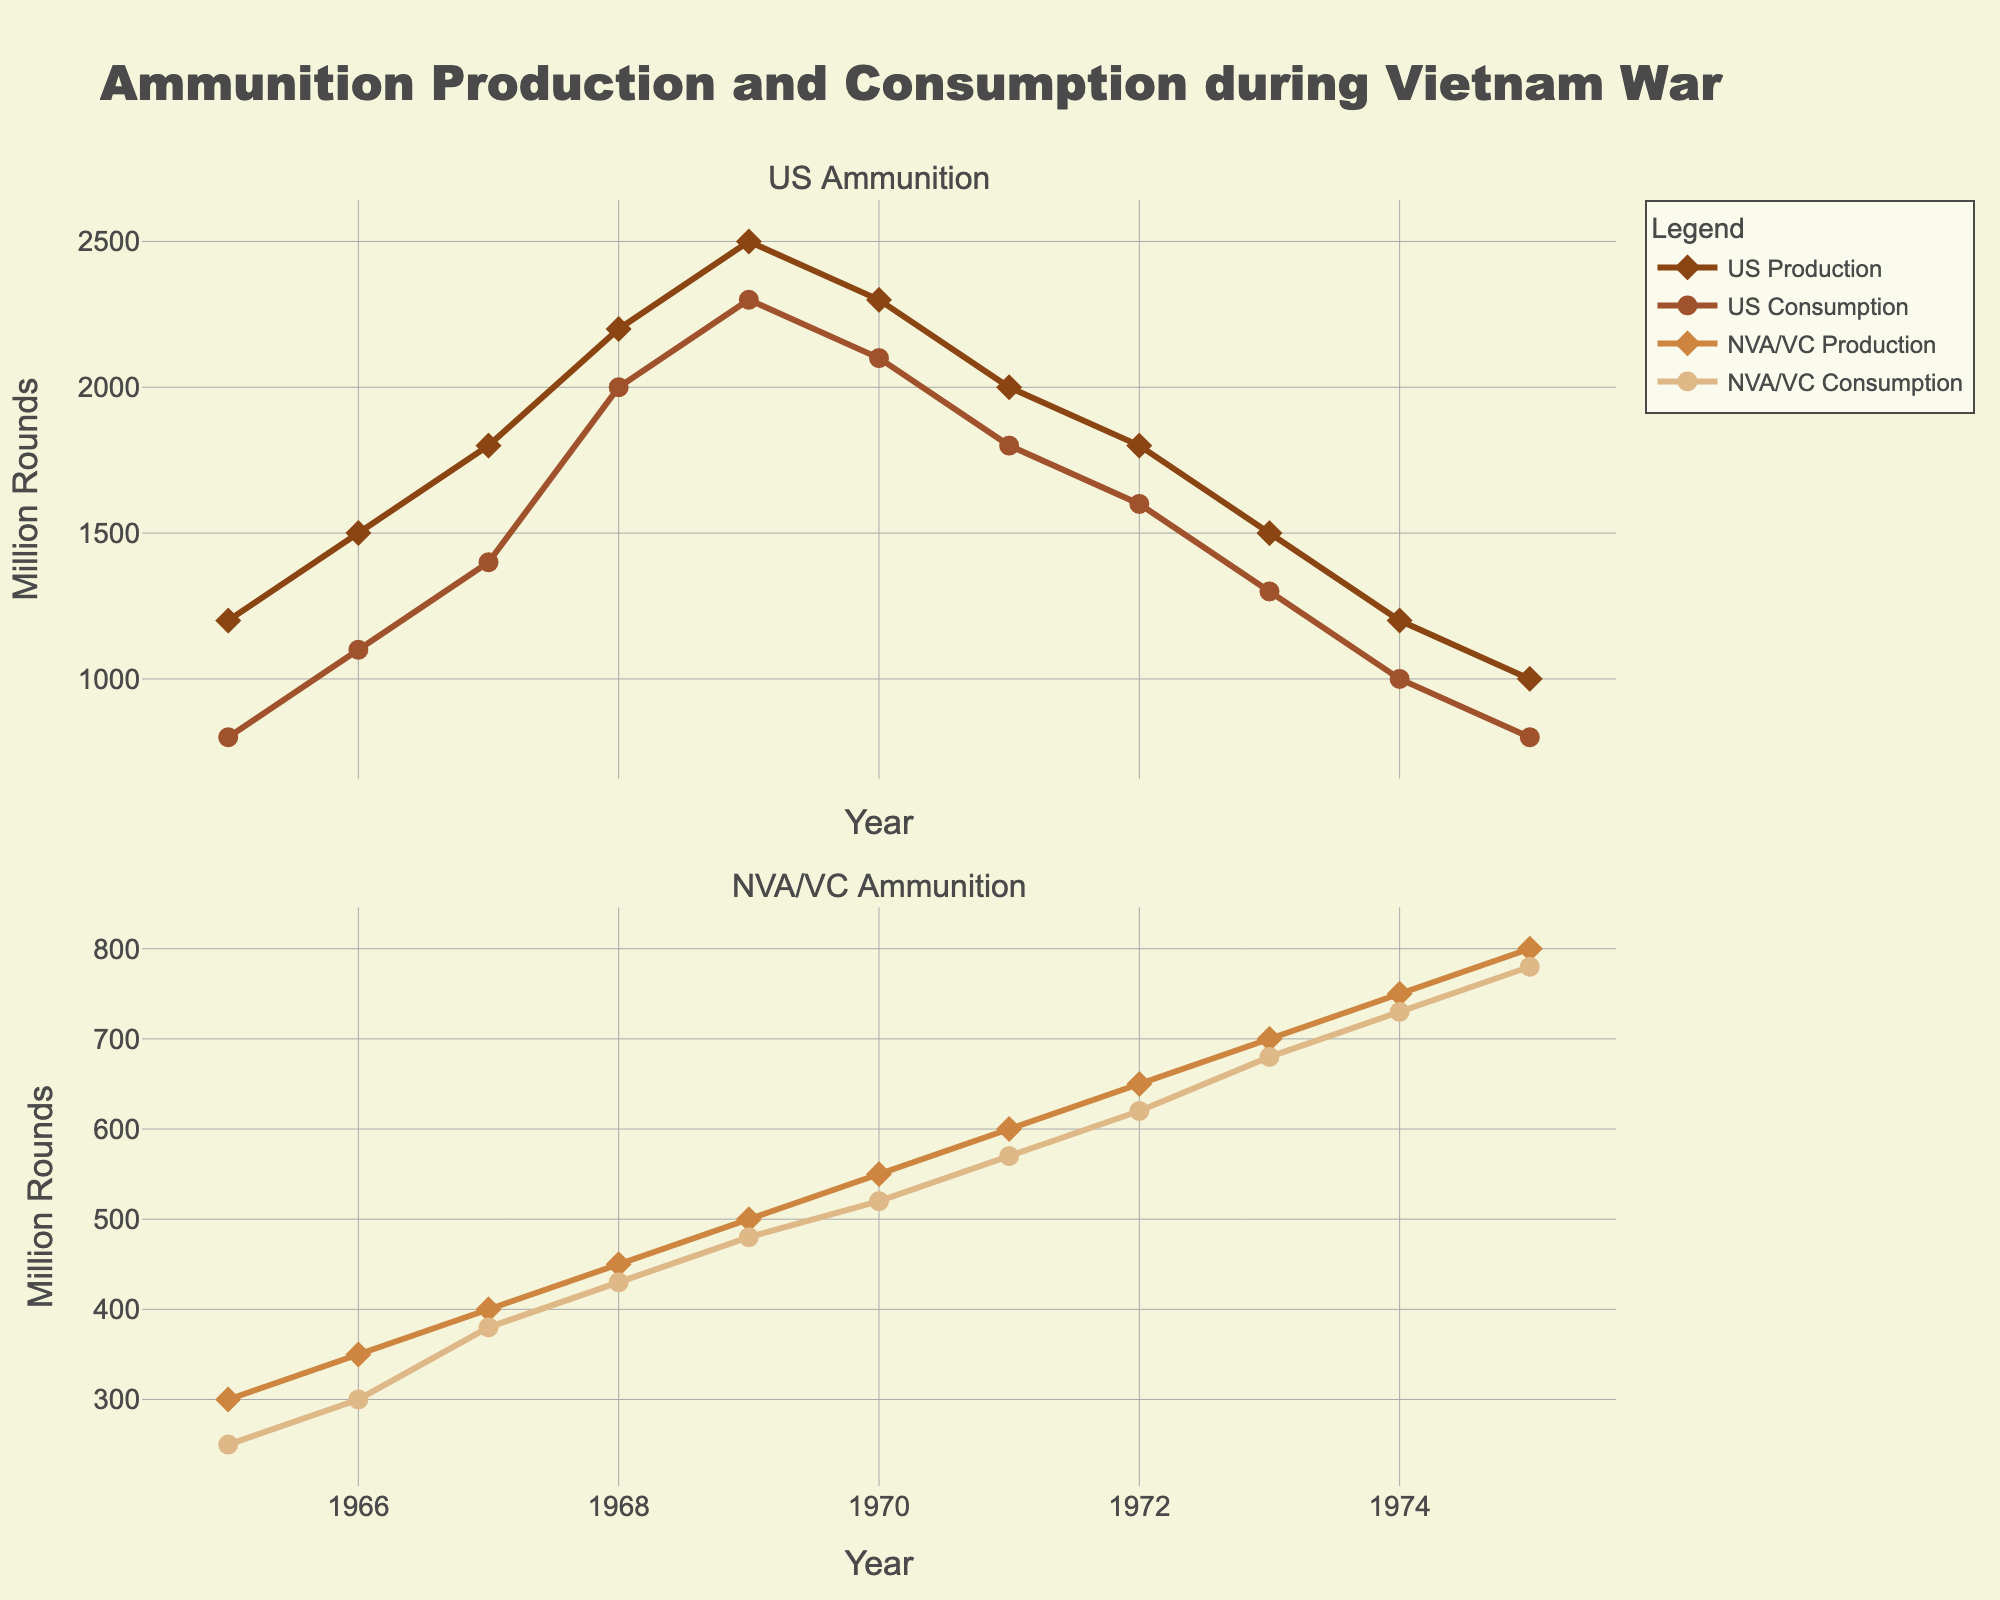What is the difference between US Ammunition Production and Consumption in 1968? The plot shows two points for US data in 1968: the production marker at 2200 million rounds and the consumption marker at 2000 million rounds. By subtracting consumption from production, we get 2200 - 2000 = 200.
Answer: 200 million rounds Between which years did US Ammunition Consumption see the largest decrease? Looking at the slope of the US Consumption line between years, the steepest negative slope indicates the largest decrease. Consumption decreases from 2300 million rounds in 1969 to 2100 million rounds in 1970, a drop of 200 million rounds.
Answer: 1969 and 1970 How does NVA/VC Ammunition Consumption in 1975 compare to its Production in the same year? The NVA/VC Consumption in 1975 is at 780 million rounds, while Production is at 800 million rounds. Consumption is slightly less than Production by 20 million rounds.
Answer: Consumption is 20 million rounds less than Production What is the average difference between US Ammunition Production and Consumption from 1965 to 1970? Sum up the differences for each year from 1965 to 1970: (1200-800) + (1500-1100) + (1800-1400) + (2200-2000) + (2500-2300) + (2300-2100) = 400 + 400 + 400 + 200 + 200 + 200 = 1800. Divide by the number of years (6): 1800 / 6 = 300.
Answer: 300 million rounds Which year had the highest NVA/VC Ammunition Consumption? By viewing the NVA/VC Consumption line, the highest point is at 1975 with 780 million rounds.
Answer: 1975 What is the trend in US Ammunition Production from 1968 to 1975? From the data points, US Production peaks at 2500 million rounds in 1969, then decreases gradually to 1000 million rounds by 1975.
Answer: Downward trend Compare the US Ammunition Production in 1965 with NVA/VC Ammunition Production in the same year. Which was higher and by how much? In 1965, US Production is 1200 million rounds and NVA/VC Production is 300 million rounds. The difference is 1200 - 300 = 900 million rounds, with US Production being higher.
Answer: US Production by 900 million rounds Which year shows the smallest difference between NVA/VC Ammunition Production and Consumption? The differences for each year are: 1965: 50, 1966: 50, 1967: 20, 1968: 20, 1969: 20, 1970: 30, 1971: 30, 1972: 30, 1973: 20, 1974: 20, 1975: 20. The smallest difference is 20, occurring in multiple years (1967, 1968, 1969, 1973, 1974, 1975).
Answer: 1967, 1968, 1969, 1973, 1974, 1975 What was the ratio of US Ammunition Consumption to Production in 1971? US Consumption in 1971 is 1800 million rounds, and Production is 2000 million rounds. The ratio is 1800 / 2000 = 0.9.
Answer: 0.9 Between which years did NVA/VC Ammunition Production continuously increase? Starting from 1965, the plot shows NVA/VC Production consistently increasing each year up to 1975.
Answer: 1965 to 1975 